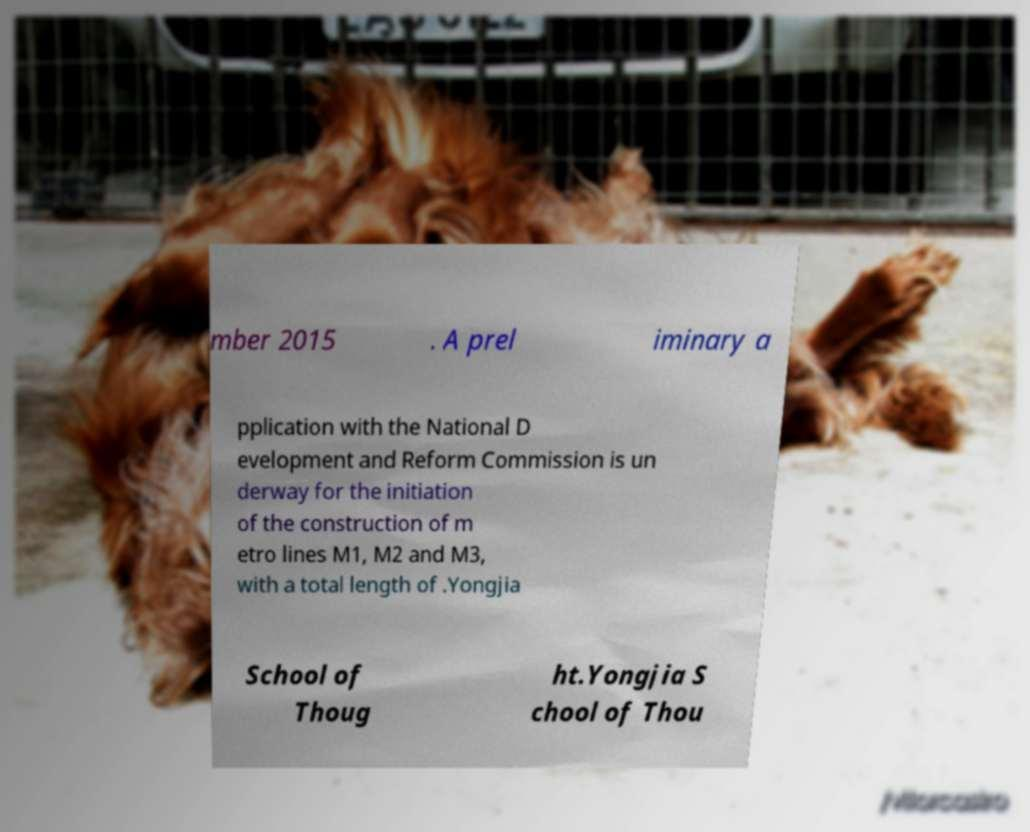There's text embedded in this image that I need extracted. Can you transcribe it verbatim? mber 2015 . A prel iminary a pplication with the National D evelopment and Reform Commission is un derway for the initiation of the construction of m etro lines M1, M2 and M3, with a total length of .Yongjia School of Thoug ht.Yongjia S chool of Thou 